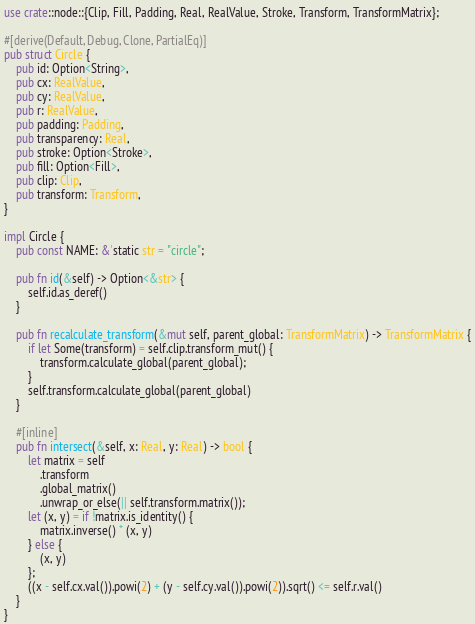Convert code to text. <code><loc_0><loc_0><loc_500><loc_500><_Rust_>use crate::node::{Clip, Fill, Padding, Real, RealValue, Stroke, Transform, TransformMatrix};

#[derive(Default, Debug, Clone, PartialEq)]
pub struct Circle {
    pub id: Option<String>,
    pub cx: RealValue,
    pub cy: RealValue,
    pub r: RealValue,
    pub padding: Padding,
    pub transparency: Real,
    pub stroke: Option<Stroke>,
    pub fill: Option<Fill>,
    pub clip: Clip,
    pub transform: Transform,
}

impl Circle {
    pub const NAME: &'static str = "circle";

    pub fn id(&self) -> Option<&str> {
        self.id.as_deref()
    }

    pub fn recalculate_transform(&mut self, parent_global: TransformMatrix) -> TransformMatrix {
        if let Some(transform) = self.clip.transform_mut() {
            transform.calculate_global(parent_global);
        }
        self.transform.calculate_global(parent_global)
    }

    #[inline]
    pub fn intersect(&self, x: Real, y: Real) -> bool {
        let matrix = self
            .transform
            .global_matrix()
            .unwrap_or_else(|| self.transform.matrix());
        let (x, y) = if !matrix.is_identity() {
            matrix.inverse() * (x, y)
        } else {
            (x, y)
        };
        ((x - self.cx.val()).powi(2) + (y - self.cy.val()).powi(2)).sqrt() <= self.r.val()
    }
}
</code> 